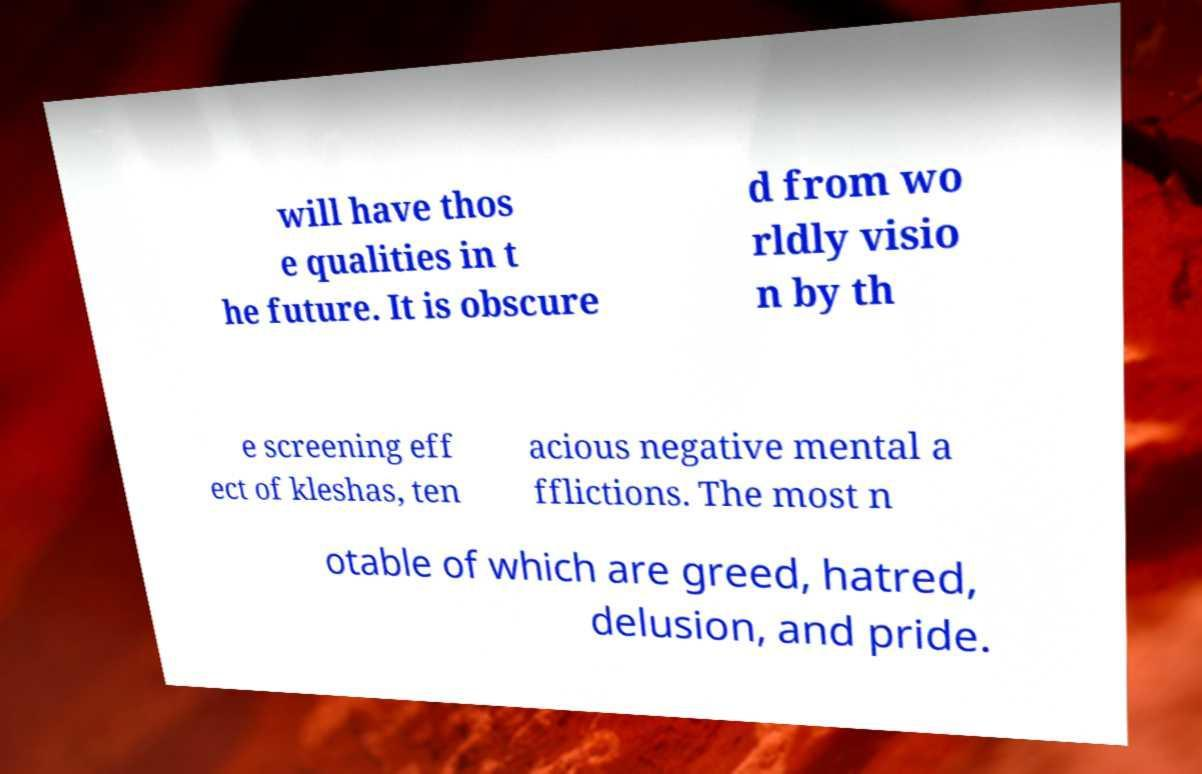Please identify and transcribe the text found in this image. will have thos e qualities in t he future. It is obscure d from wo rldly visio n by th e screening eff ect of kleshas, ten acious negative mental a fflictions. The most n otable of which are greed, hatred, delusion, and pride. 